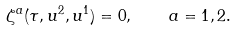<formula> <loc_0><loc_0><loc_500><loc_500>\zeta ^ { a } ( \tau , u ^ { 2 } , u ^ { 1 } ) = 0 , \quad a = 1 , 2 .</formula> 